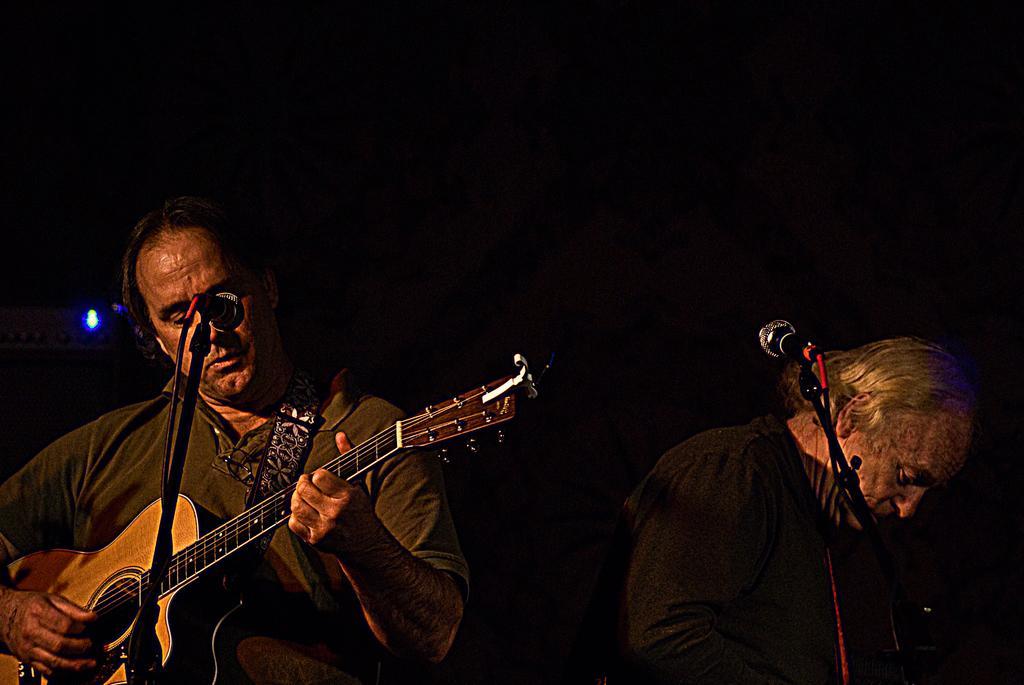Please provide a concise description of this image. There are two persons are playing a guitar. He is standing his playing a guitar. There is a microphone. 